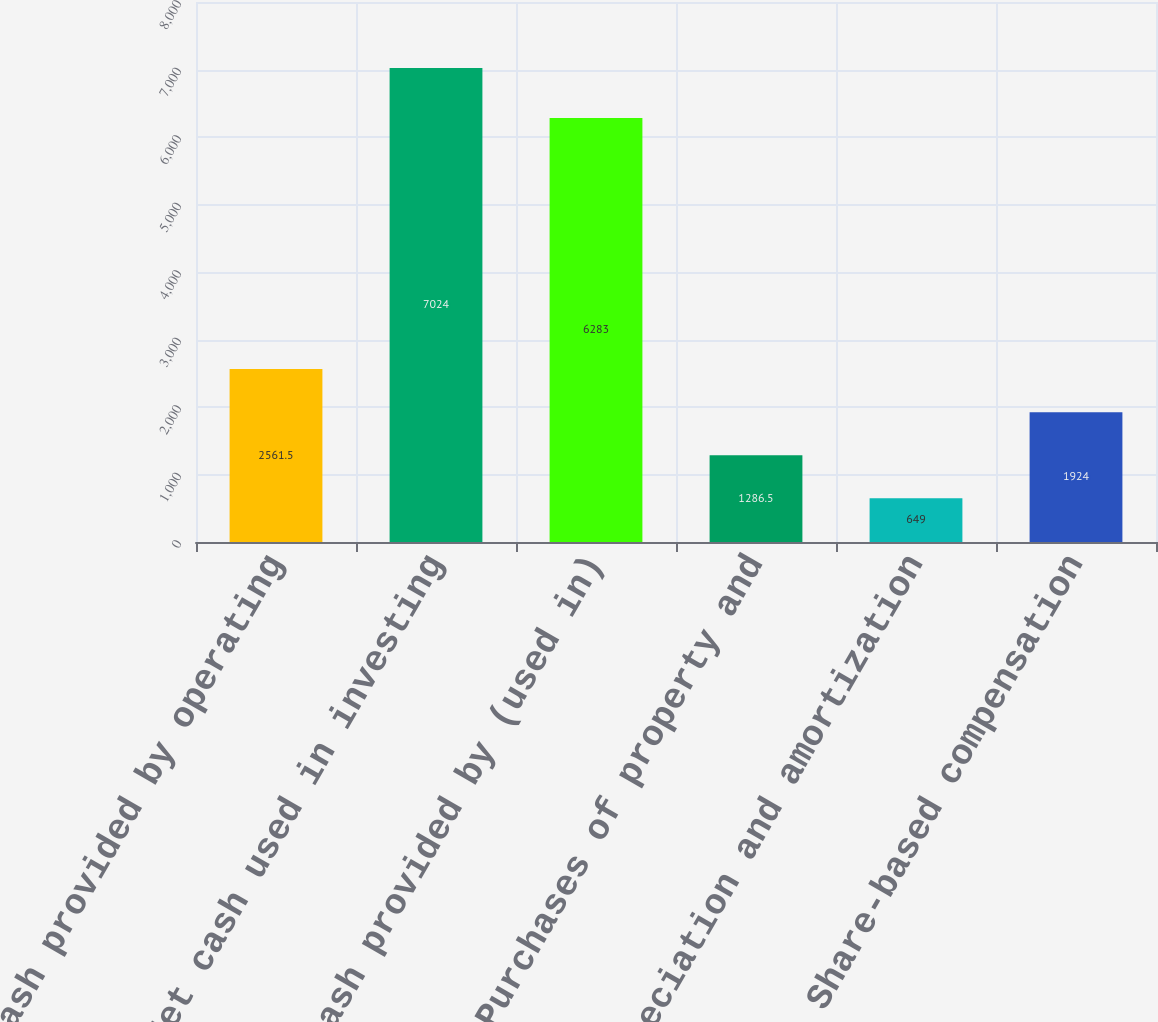Convert chart to OTSL. <chart><loc_0><loc_0><loc_500><loc_500><bar_chart><fcel>Net cash provided by operating<fcel>Net cash used in investing<fcel>Net cash provided by (used in)<fcel>Purchases of property and<fcel>Depreciation and amortization<fcel>Share-based compensation<nl><fcel>2561.5<fcel>7024<fcel>6283<fcel>1286.5<fcel>649<fcel>1924<nl></chart> 